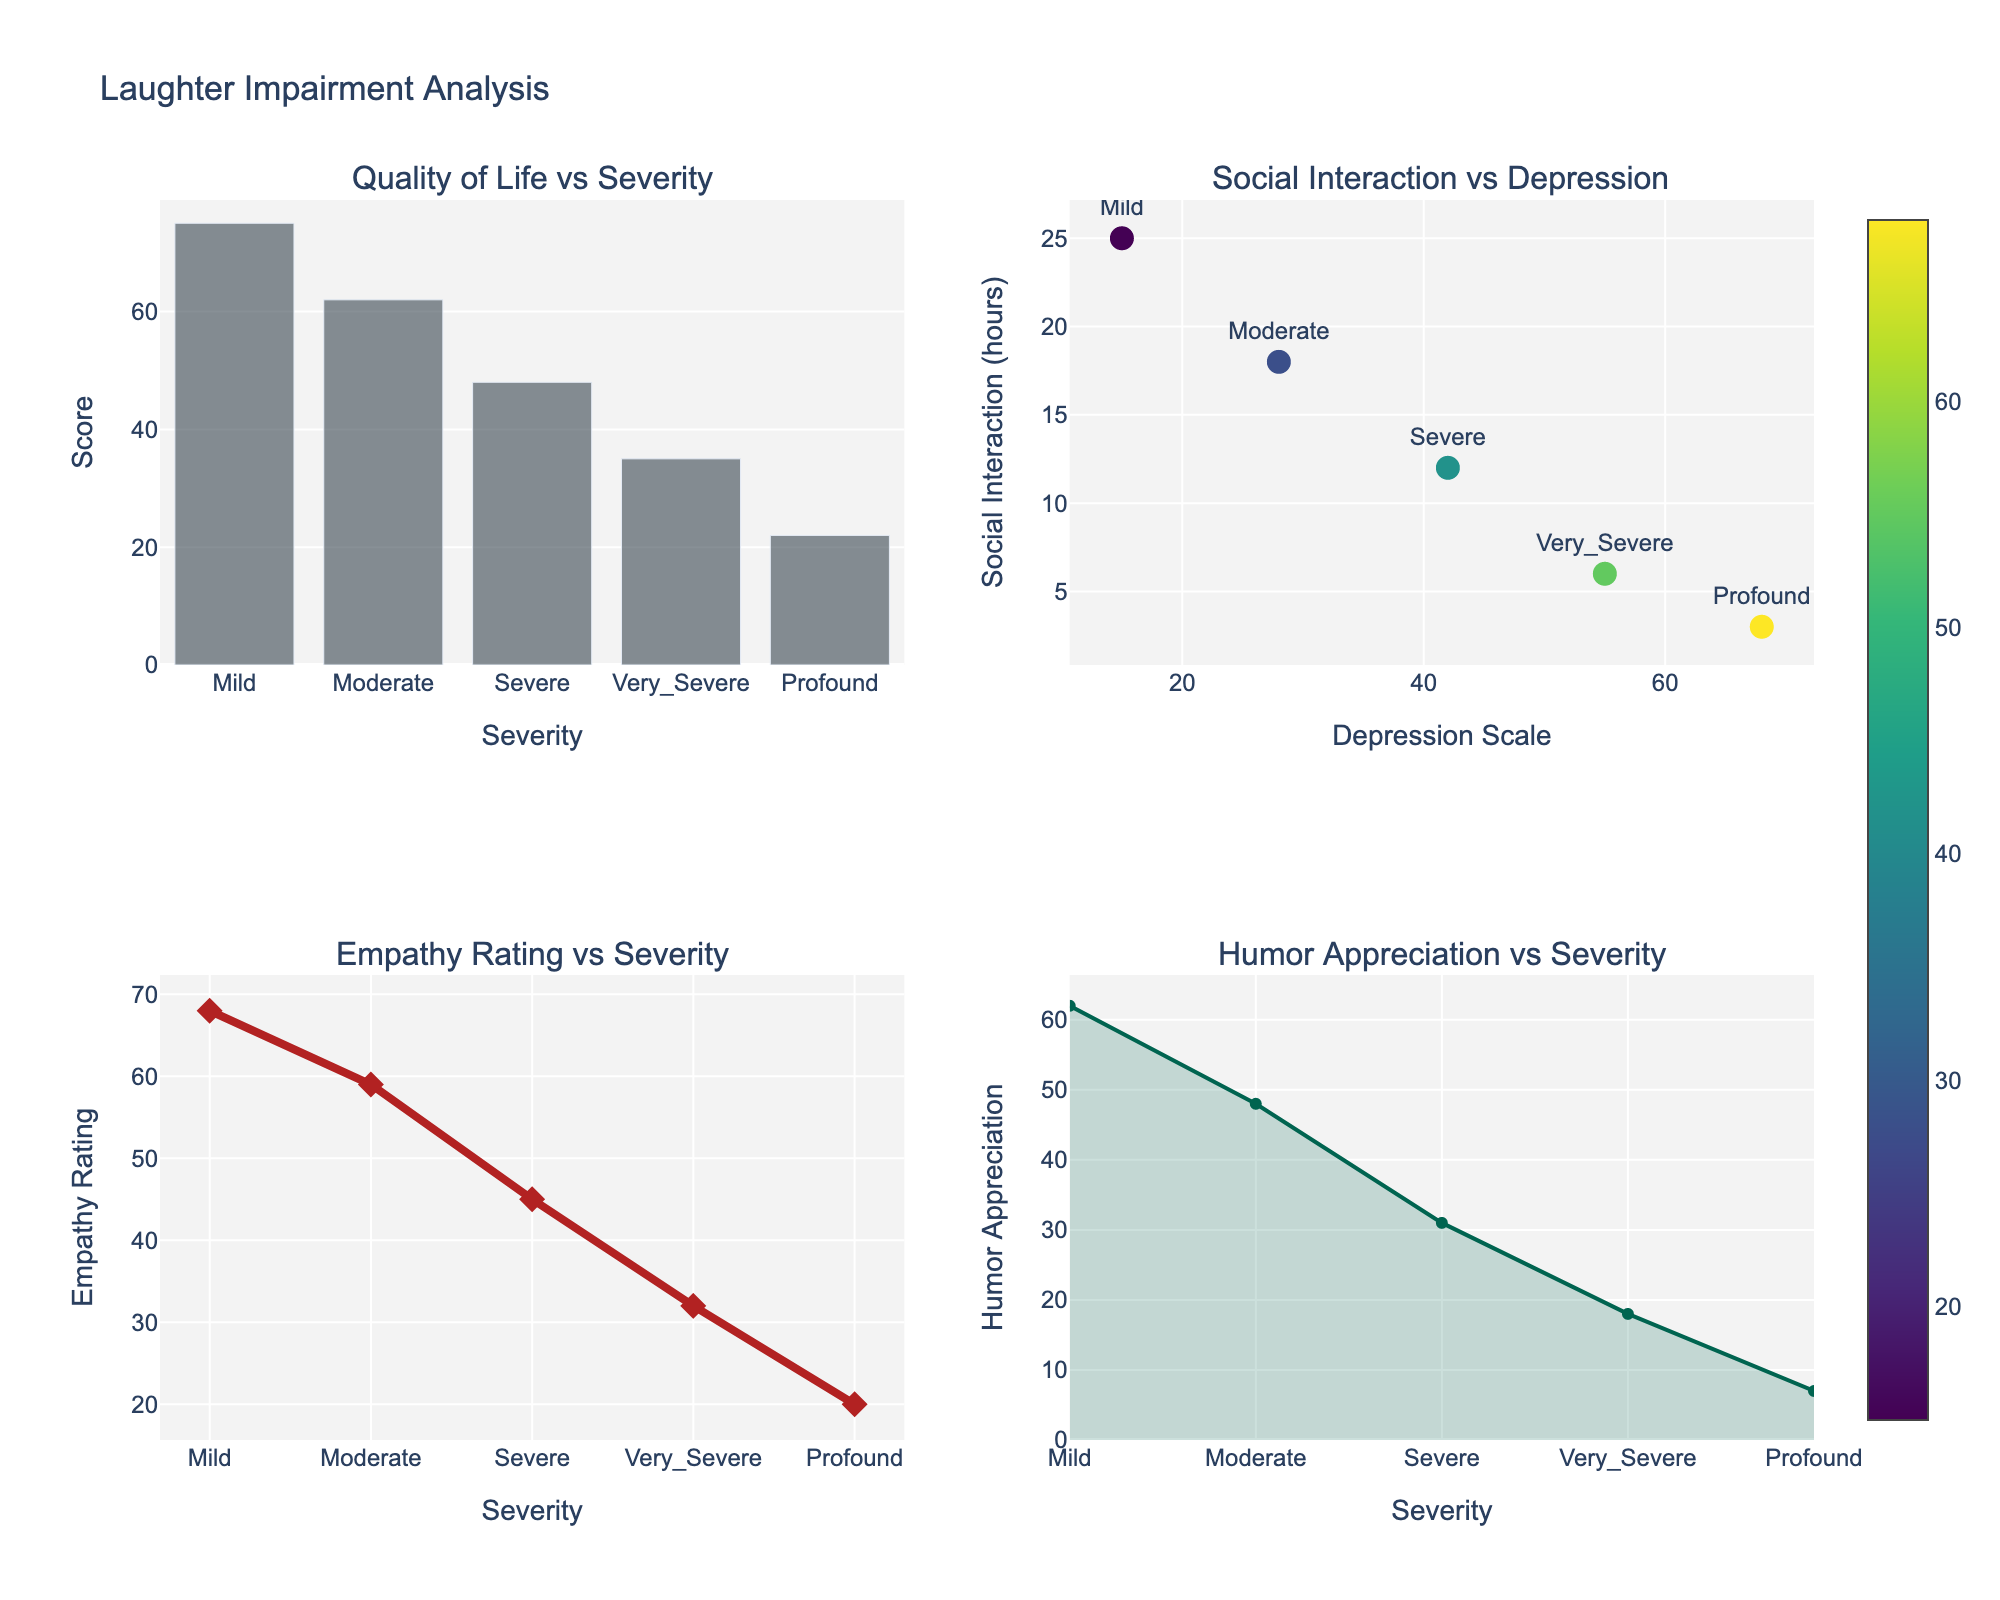What is the title of the figure? The title of the figure is displayed at the top of the plot. It reads "Laughter Impairment Analysis".
Answer: Laughter Impairment Analysis Which severity level has the highest Quality of Life Score? Refer to the bar chart in the first subplot, which shows Quality of Life Scores for different severity levels. The highest bar corresponds to the "Mild" severity level.
Answer: Mild How does Social Interaction Hours change as the Depression Scale increases? The scatter plot in the second subplot shows Social Interaction Hours against the Depression Scale. Observing the plot, as the Depression Scale increases, Social Interaction Hours decrease.
Answer: Decrease Which severity level has the lowest Empathy Rating? The line plot in the third subplot shows Empathy Ratings for different severity levels. The lowest point on the graph corresponds to the "Profound" severity level.
Answer: Profound What is the maximum value on the Humor Appreciation scale in the figure? Look at the area plot in the fourth subplot that shows Humor Appreciation against severity levels. The maximum point on this plot is located at the "Mild" severity level, with a value of 62.
Answer: 62 Is there a general trend between severity levels and Quality of Life Scores? Examine the bar chart in the first subplot where Quality of Life Scores are plotted against severity levels. As severity increases, Quality of Life Scores generally decrease.
Answer: Decrease Compare the Social Interaction Hours between "Moderate" and "Very Severe" severity levels. Which one is higher? In the scatter plot (second subplot), find the data points corresponding to "Moderate" and "Very Severe" severity levels. "Moderate" shows 18 hours while "Very Severe" shows 6 hours of social interaction. Therefore, "Moderate" has higher hours.
Answer: Moderate Which empathy rating (highest or lowest) corresponds to a "Severe" severity level? Referring to the line plot (third subplot), the empathy rating for "Severe" severity level is moderately high compared to others, specifically at 45.
Answer: Moderately high What severity level shows the largest drop in Humor Appreciation from the previous severity level? Examine the area plot (fourth subplot) for a significant drop between consecutive severity levels. The drop from "Moderate" to "Severe" shows the largest decrease.
Answer: Moderate to Severe By how much does the Quality of Life Score decrease from "Mild" to "Moderate" severity? In the bar chart (first subplot), compare the heights of the bars for "Mild" (75) and "Moderate" (62). The decrease is calculated as 75 - 62 = 13.
Answer: 13 